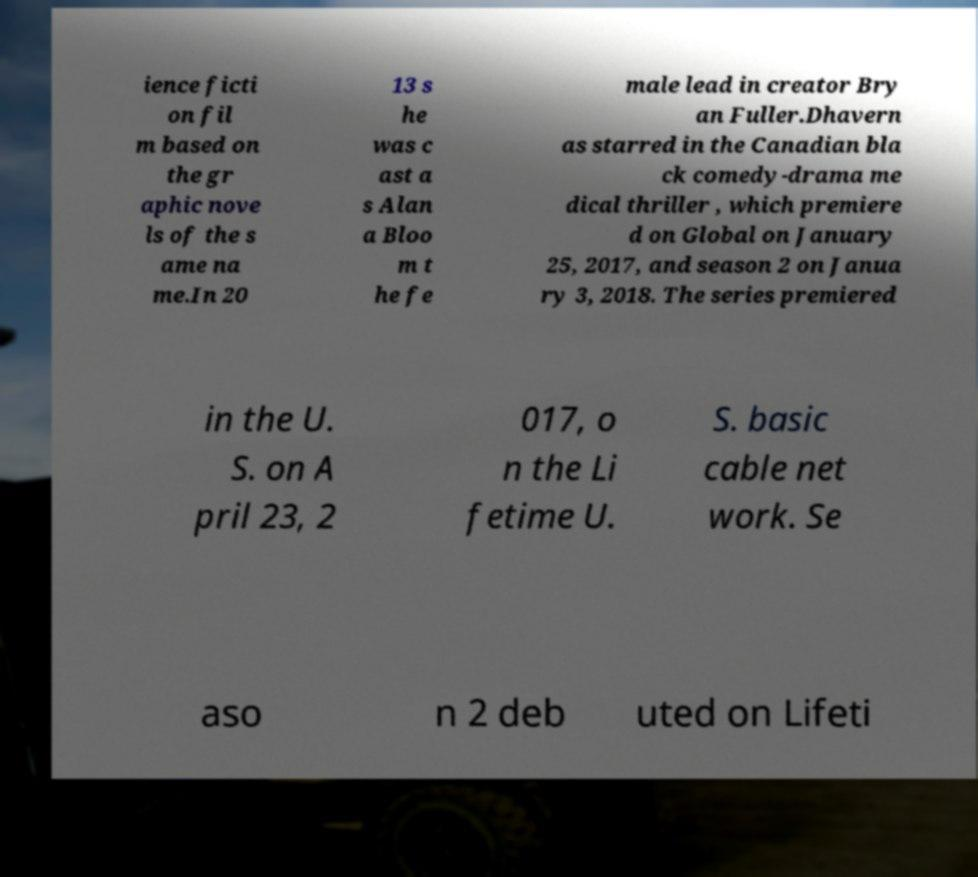Could you assist in decoding the text presented in this image and type it out clearly? ience ficti on fil m based on the gr aphic nove ls of the s ame na me.In 20 13 s he was c ast a s Alan a Bloo m t he fe male lead in creator Bry an Fuller.Dhavern as starred in the Canadian bla ck comedy-drama me dical thriller , which premiere d on Global on January 25, 2017, and season 2 on Janua ry 3, 2018. The series premiered in the U. S. on A pril 23, 2 017, o n the Li fetime U. S. basic cable net work. Se aso n 2 deb uted on Lifeti 